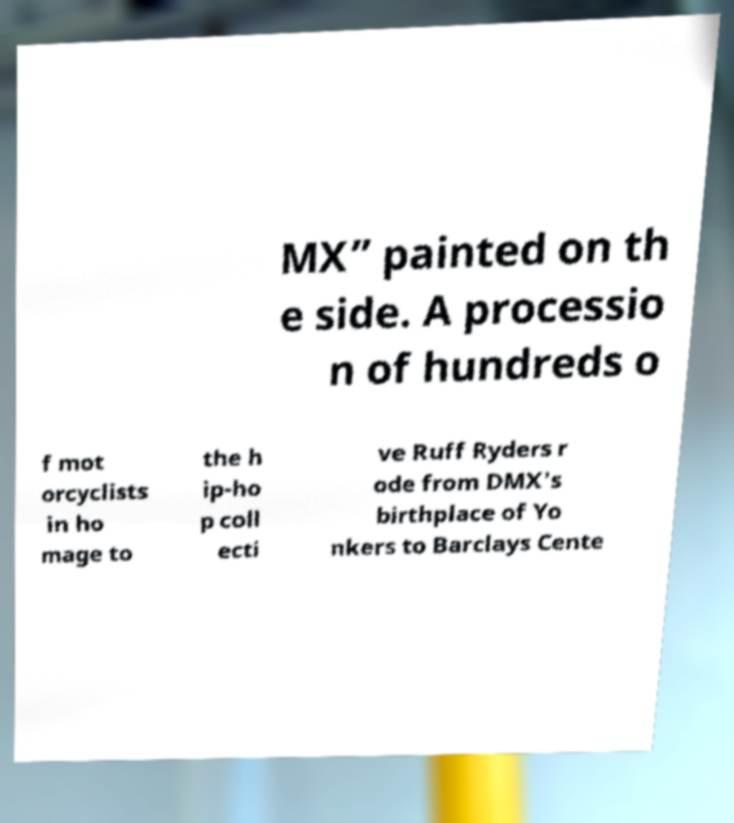Can you accurately transcribe the text from the provided image for me? MX” painted on th e side. A processio n of hundreds o f mot orcyclists in ho mage to the h ip-ho p coll ecti ve Ruff Ryders r ode from DMX's birthplace of Yo nkers to Barclays Cente 